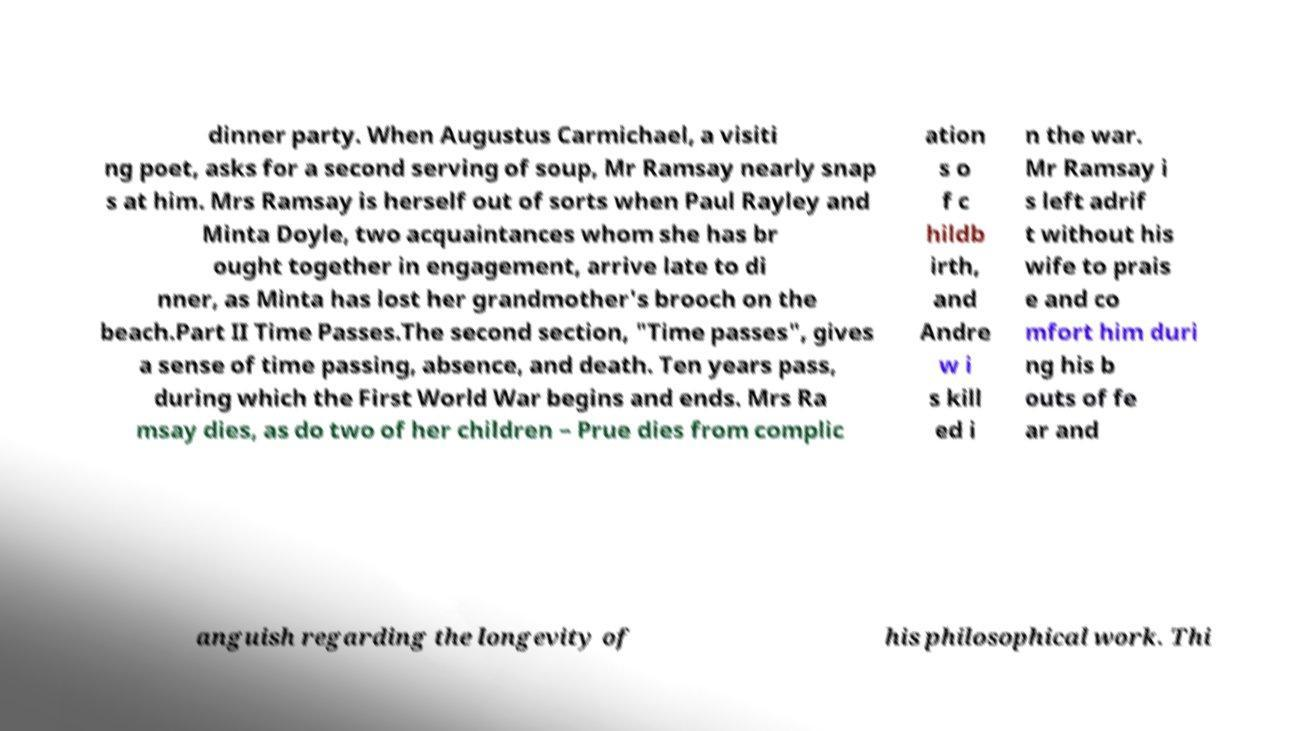Can you read and provide the text displayed in the image?This photo seems to have some interesting text. Can you extract and type it out for me? dinner party. When Augustus Carmichael, a visiti ng poet, asks for a second serving of soup, Mr Ramsay nearly snap s at him. Mrs Ramsay is herself out of sorts when Paul Rayley and Minta Doyle, two acquaintances whom she has br ought together in engagement, arrive late to di nner, as Minta has lost her grandmother's brooch on the beach.Part II Time Passes.The second section, "Time passes", gives a sense of time passing, absence, and death. Ten years pass, during which the First World War begins and ends. Mrs Ra msay dies, as do two of her children – Prue dies from complic ation s o f c hildb irth, and Andre w i s kill ed i n the war. Mr Ramsay i s left adrif t without his wife to prais e and co mfort him duri ng his b outs of fe ar and anguish regarding the longevity of his philosophical work. Thi 